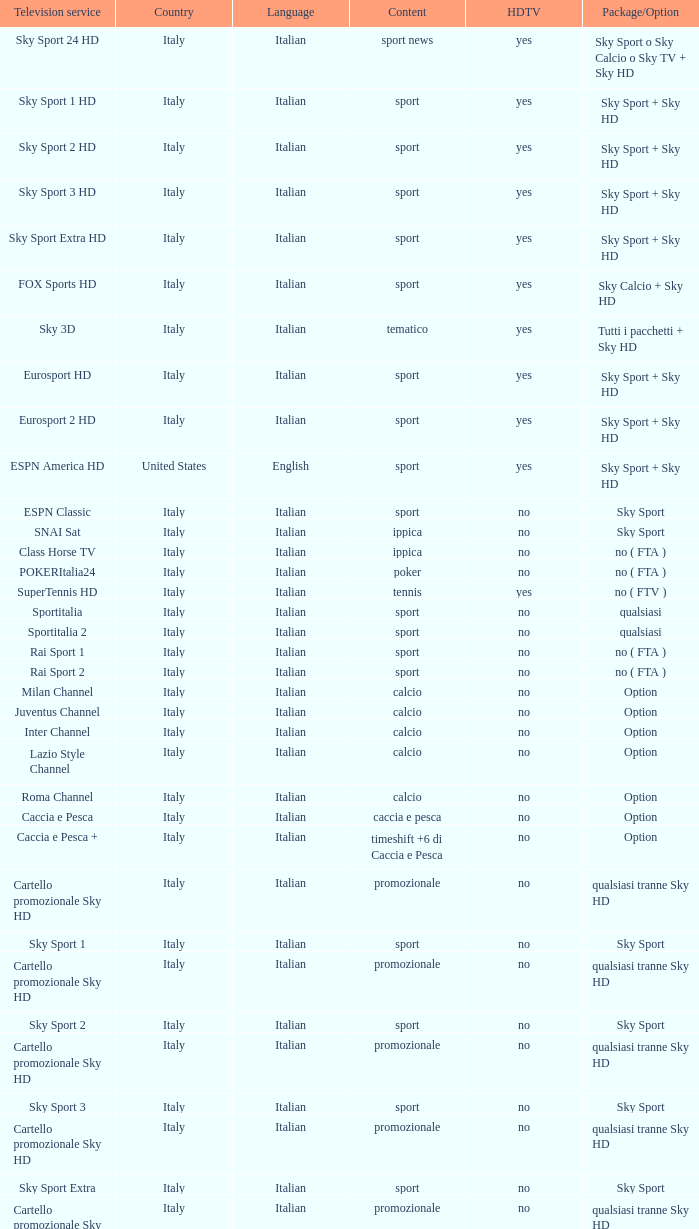What does the term package/option mean when discussing tennis content? No ( ftv ). 